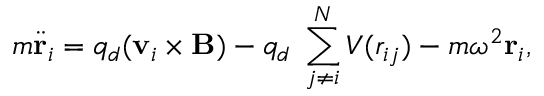<formula> <loc_0><loc_0><loc_500><loc_500>m \ddot { r } _ { i } = q _ { d } ( v _ { i } \times B ) - q _ { d } \nabla \sum _ { j \neq i } ^ { N } V ( r _ { i j } ) - m \omega ^ { 2 } r _ { i } ,</formula> 